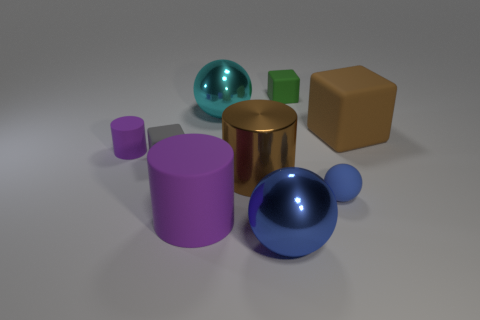Subtract all blue spheres. How many purple cylinders are left? 2 Subtract 1 spheres. How many spheres are left? 2 Subtract all tiny green cubes. How many cubes are left? 2 Subtract all blue cylinders. Subtract all red balls. How many cylinders are left? 3 Subtract all cylinders. How many objects are left? 6 Subtract 0 green cylinders. How many objects are left? 9 Subtract all red matte cylinders. Subtract all big purple objects. How many objects are left? 8 Add 7 small purple matte cylinders. How many small purple matte cylinders are left? 8 Add 3 metallic cylinders. How many metallic cylinders exist? 4 